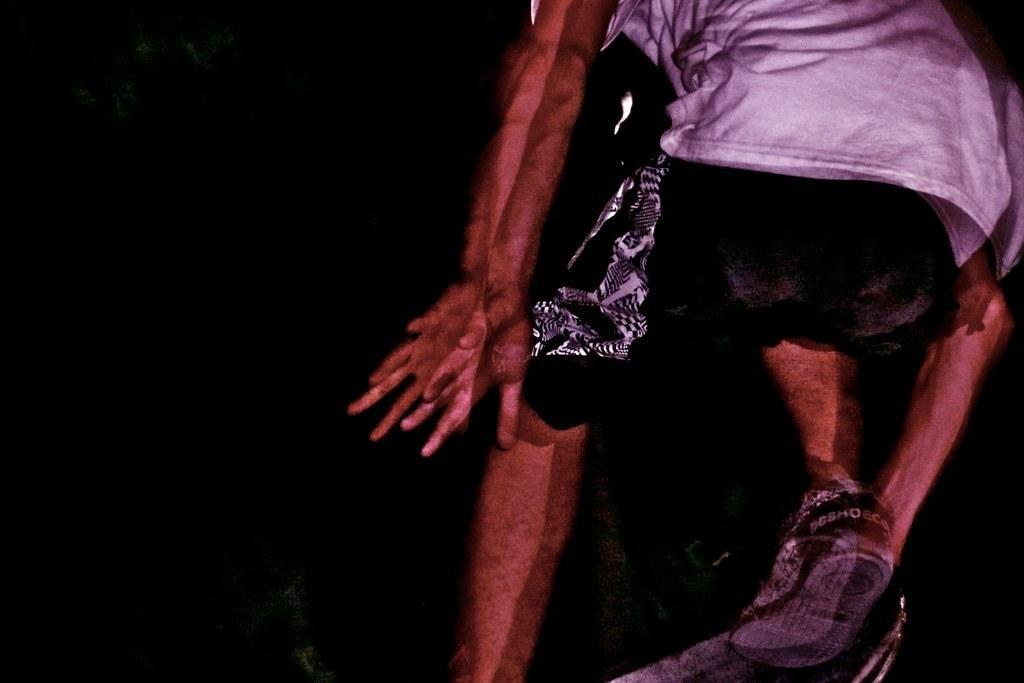What is happening in the image? There is a person in the image, and the person is running. What can be seen in the background of the image? The background of the image is black. What type of orange is the person holding in the image? There is no orange present in the image; the person is running, and the background is black. 